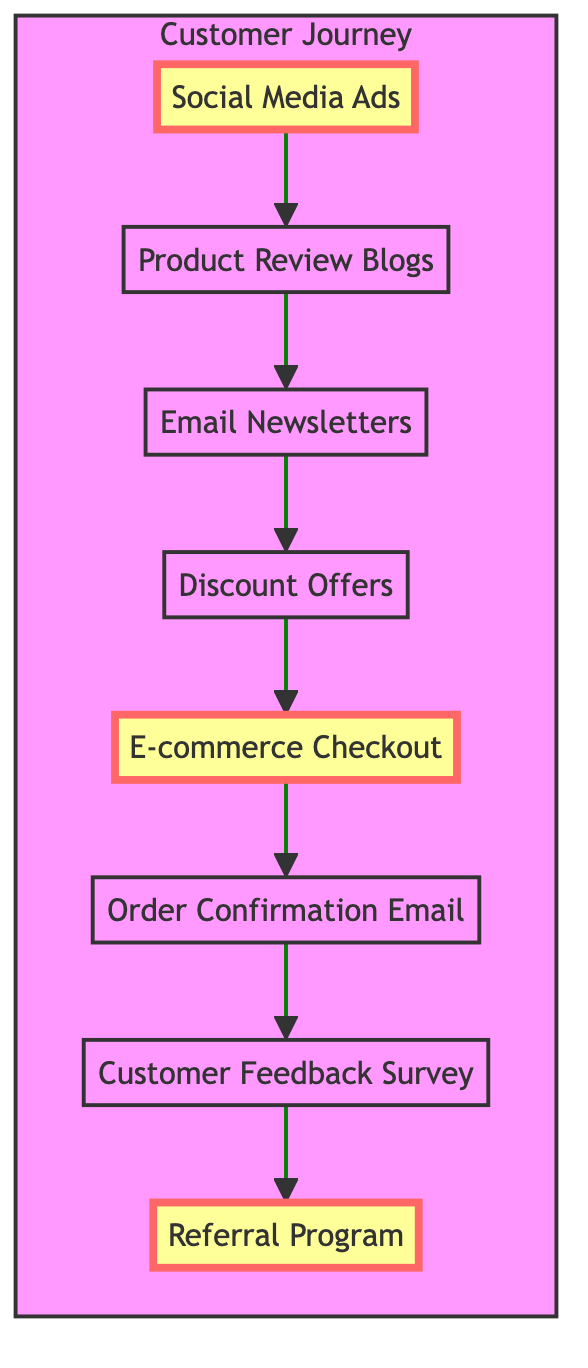What is the first step in the customer journey? The first step is represented by the "Awareness" node, which indicates the initial stage of the customer journey. In this diagram, this is shown as "Social Media Ads".
Answer: Social Media Ads How many nodes are present in the diagram? To find the number of nodes, count each unique step in the customer journey. There are 8 nodes: Awareness, Interest, Consideration, Intent, Purchase, Post-Purchase, Loyalty, and Advocacy.
Answer: 8 What is the last step of the customer journey? The last step is represented by the "Advocacy" node, which signifies the final stage of the customer journey. In this diagram, it is shown as "Referral Program".
Answer: Referral Program Which two stages come before the Purchase stage? To answer this, follow the directed edges before reaching the "Purchase" node. The stages directly leading to "Purchase" are "Intent" and "Consideration".
Answer: Intent and Consideration What is the relationship between the Interest and Consideration stages? The directional edge from "Interest" to "Consideration" indicates that customers transition from the Interest stage to the Consideration stage. This represents a flow in the customer journey.
Answer: Interest to Consideration Which stage has no outgoing edges? To determine this, examine the outgoing connections of each node. The "Referral Program" (Advocacy) does not have any outgoing edges, indicating the end of the journey with no further actions.
Answer: Referral Program How many edges are there in total? Count each direct connection (edge) between the nodes that represent the customer journey. There are 7 edges established in the diagram.
Answer: 7 What is the primary action taken in the Intent stage? The action at this stage is denoted by the "Discount Offers" node, which represents what customers encounter as they express intent to purchase.
Answer: Discount Offers 